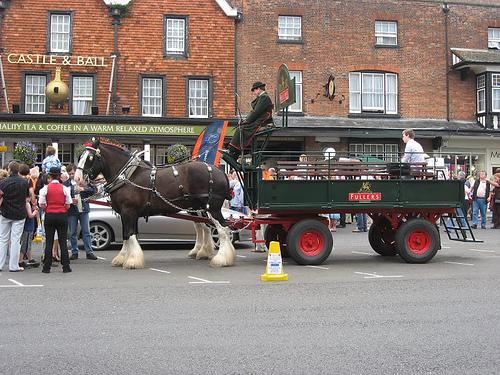What color are the bearings inside of the wagon wheels?

Choices:
A) white
B) purple
C) blue
D) red red 